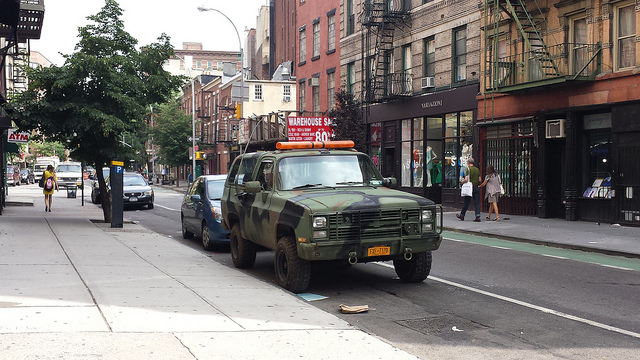How many cars are there? I can see a total of three cars parked alongside the street. The first one in the foreground is a distinct, rugged-looking olive green vehicle, and there are two more cars in the background with varying colors. 